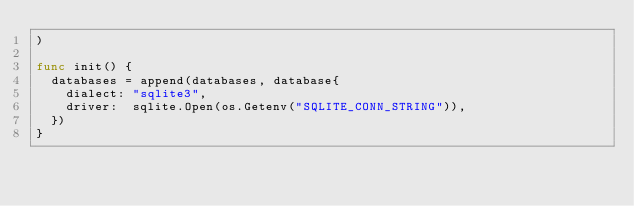Convert code to text. <code><loc_0><loc_0><loc_500><loc_500><_Go_>)

func init() {
	databases = append(databases, database{
		dialect: "sqlite3",
		driver:  sqlite.Open(os.Getenv("SQLITE_CONN_STRING")),
	})
}
</code> 